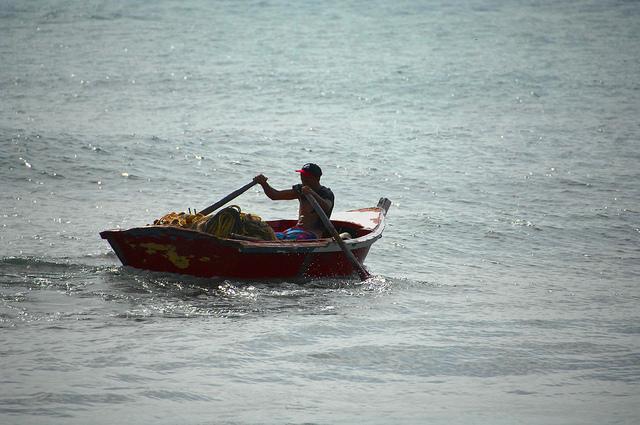How many boats are in this scene?
Give a very brief answer. 1. 